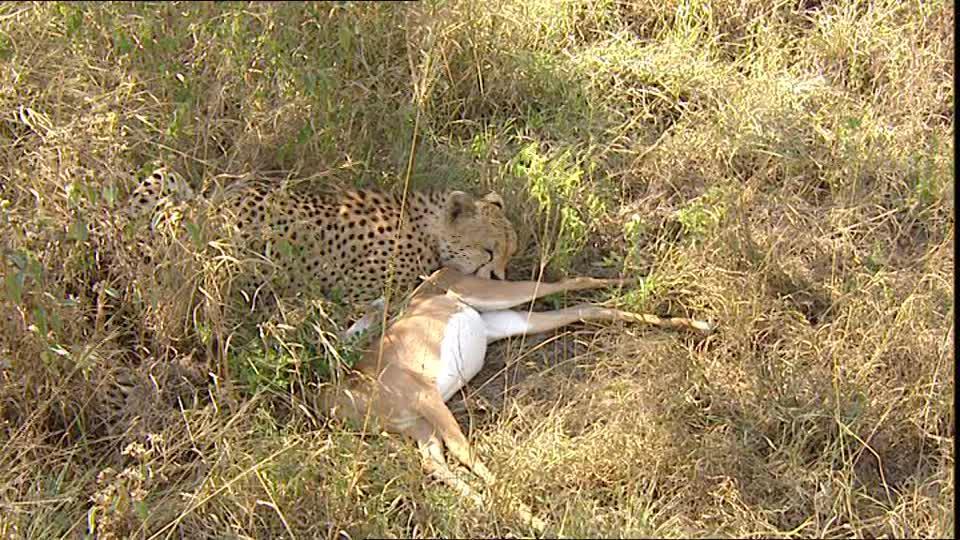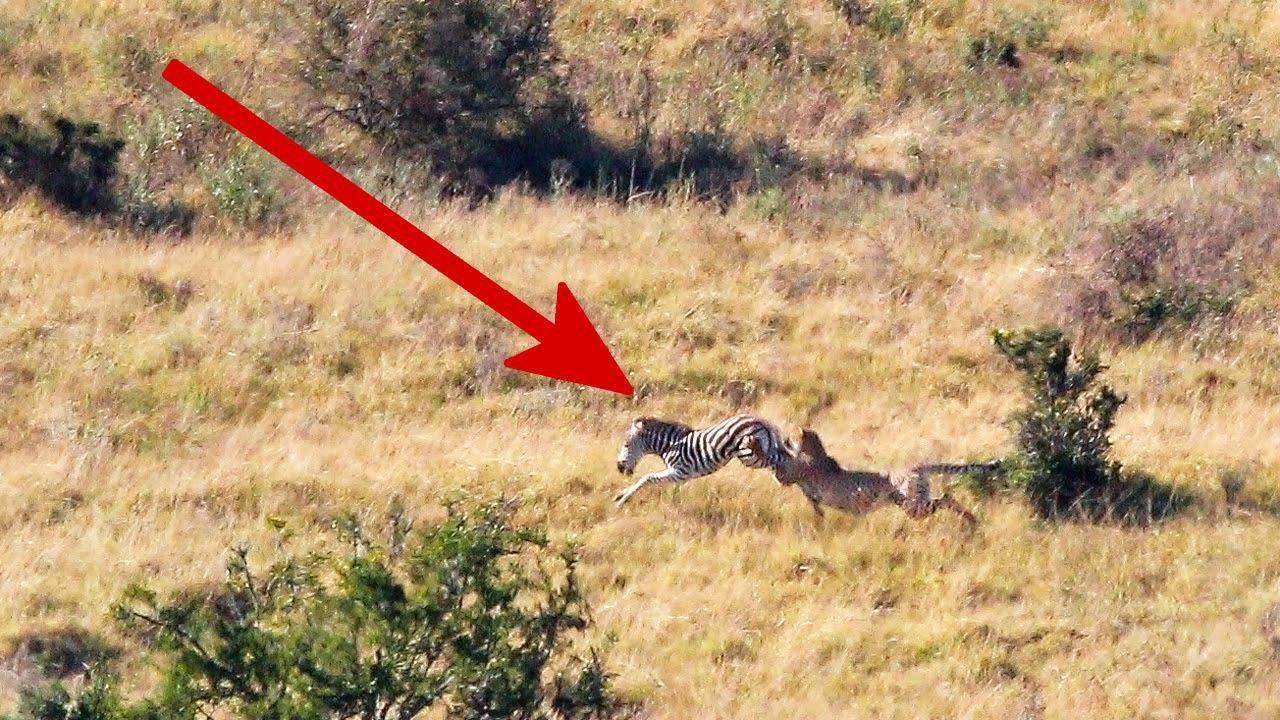The first image is the image on the left, the second image is the image on the right. Assess this claim about the two images: "There are two baby cheetahs hunting a baby gazelle.". Correct or not? Answer yes or no. No. 